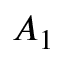Convert formula to latex. <formula><loc_0><loc_0><loc_500><loc_500>A _ { 1 }</formula> 